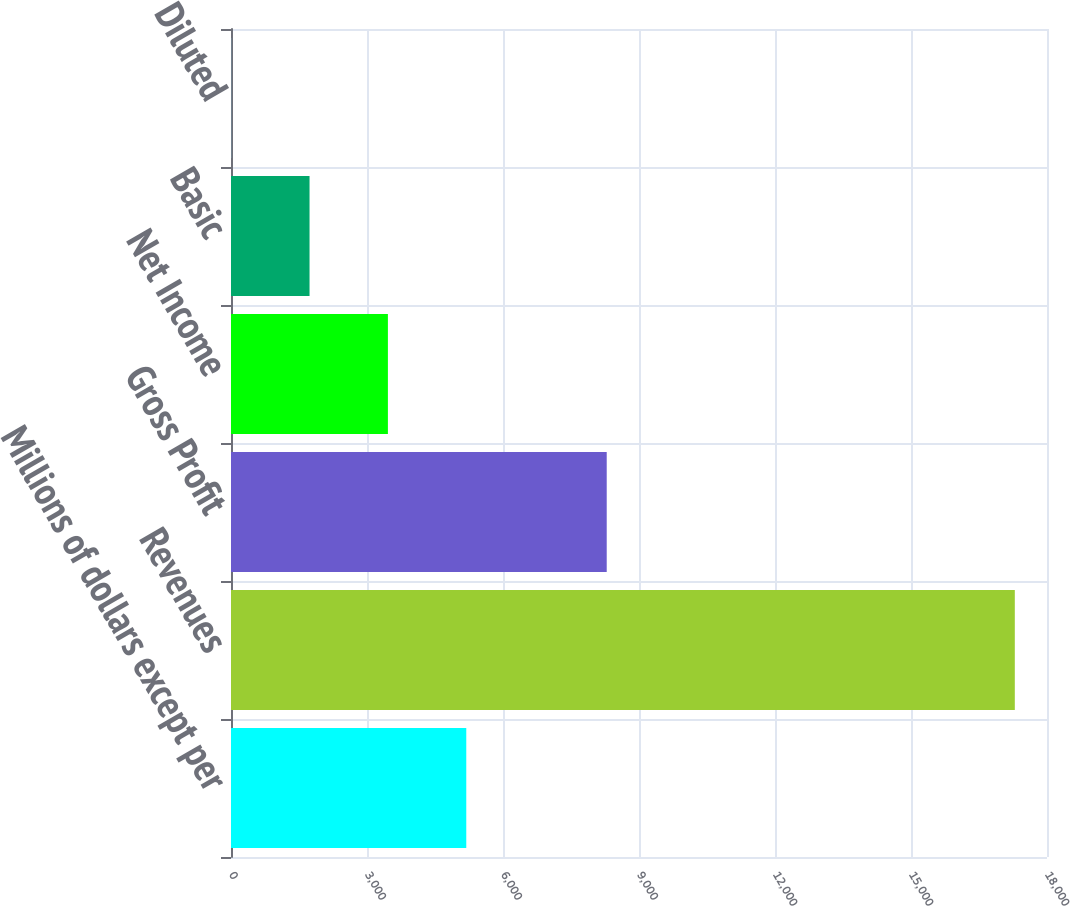Convert chart. <chart><loc_0><loc_0><loc_500><loc_500><bar_chart><fcel>Millions of dollars except per<fcel>Revenues<fcel>Gross Profit<fcel>Net Income<fcel>Basic<fcel>Diluted<nl><fcel>5189.77<fcel>17290<fcel>8288<fcel>3461.16<fcel>1732.55<fcel>3.94<nl></chart> 